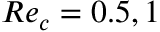Convert formula to latex. <formula><loc_0><loc_0><loc_500><loc_500>R e _ { c } = 0 . 5 , 1</formula> 